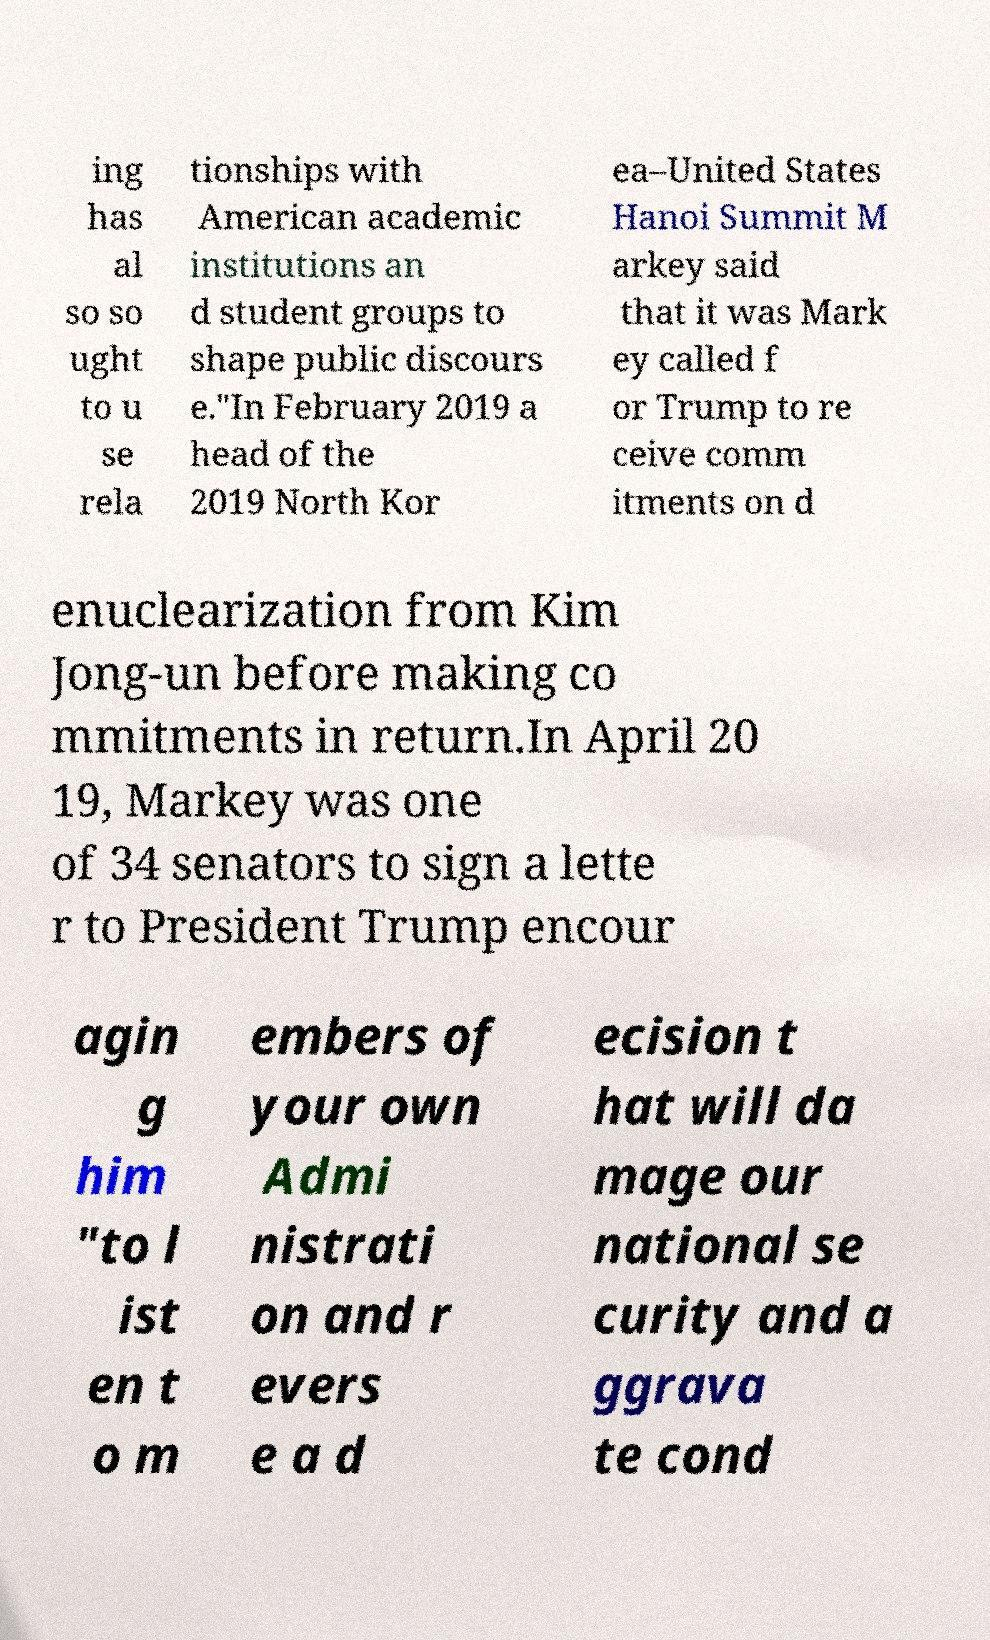Could you extract and type out the text from this image? ing has al so so ught to u se rela tionships with American academic institutions an d student groups to shape public discours e."In February 2019 a head of the 2019 North Kor ea–United States Hanoi Summit M arkey said that it was Mark ey called f or Trump to re ceive comm itments on d enuclearization from Kim Jong-un before making co mmitments in return.In April 20 19, Markey was one of 34 senators to sign a lette r to President Trump encour agin g him "to l ist en t o m embers of your own Admi nistrati on and r evers e a d ecision t hat will da mage our national se curity and a ggrava te cond 